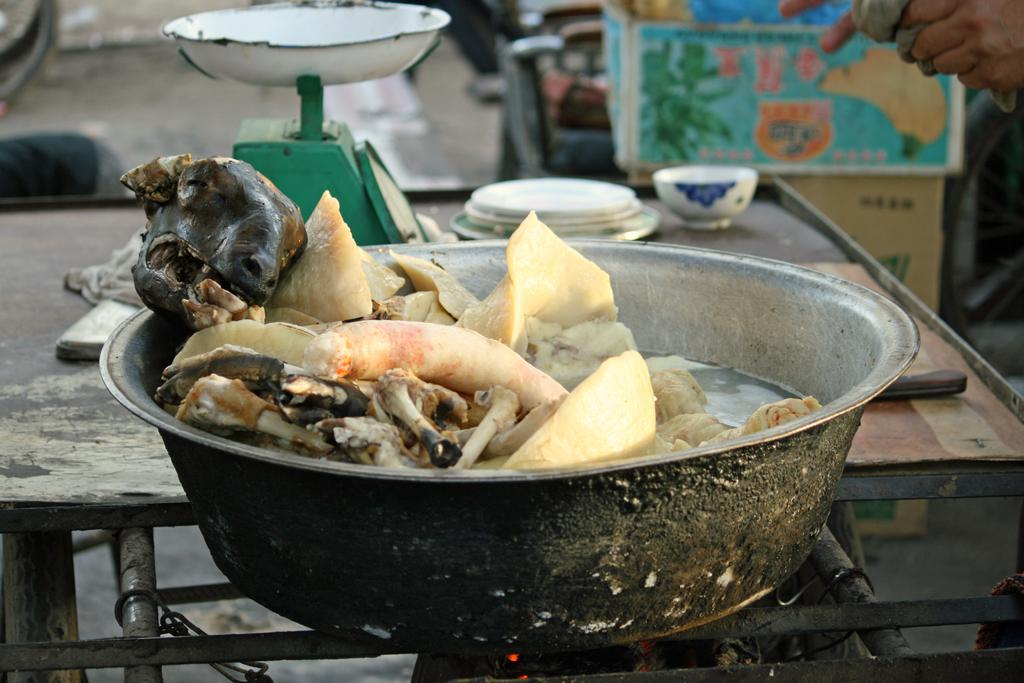What type of food is in the bowl in the image? There is goat meat in a bowl in the image. What celestial bodies can be seen in the image? Planets are visible in the image. What device is used for measuring weight in the image? A weighing machine is present in the image. Whose hands are visible in the image? Human hands are visible in the image. What utensil is present in the image? There is a knife in the image. What is on the table in the image? There is a bowl on the table in the image. How does the truck move around in the image? There is no truck present in the image. What type of quilt is covering the planets in the image? There is no quilt present in the image, and the planets are not covered. 